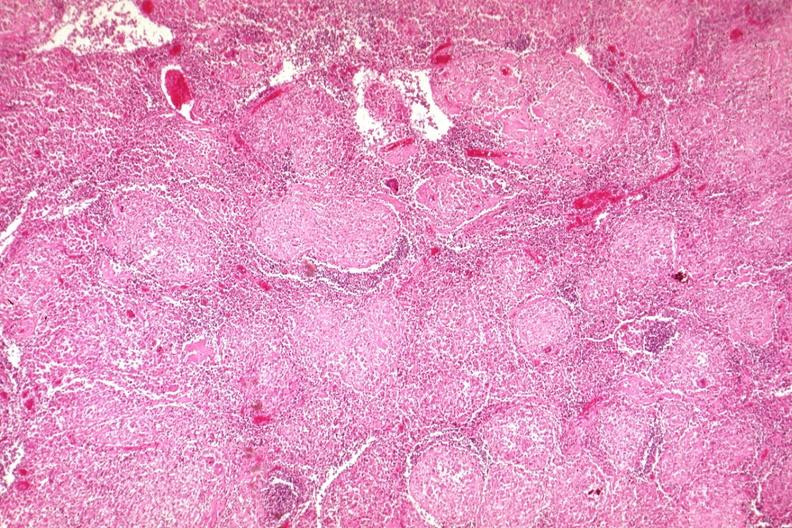what is present?
Answer the question using a single word or phrase. Lymph node 